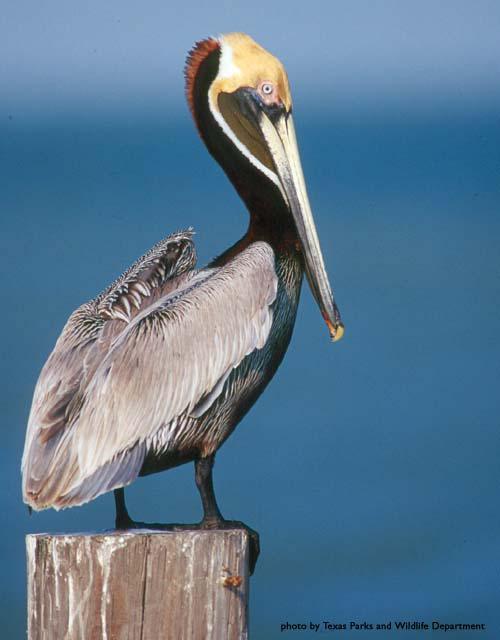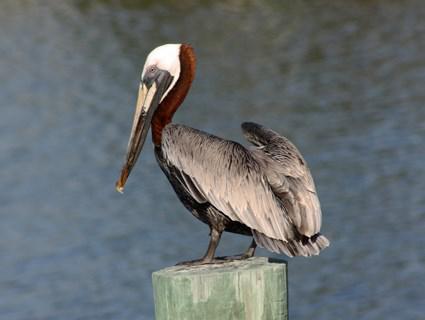The first image is the image on the left, the second image is the image on the right. For the images shown, is this caption "There is one flying bird." true? Answer yes or no. No. 